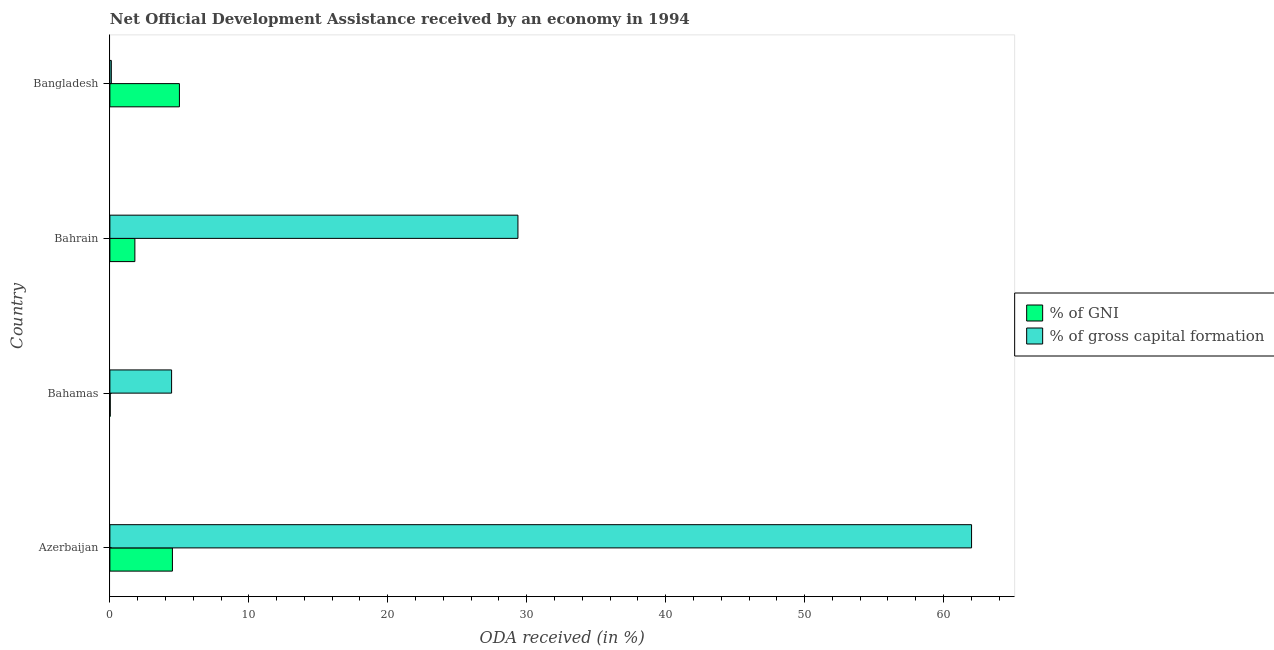Are the number of bars per tick equal to the number of legend labels?
Provide a succinct answer. Yes. Are the number of bars on each tick of the Y-axis equal?
Your answer should be compact. Yes. How many bars are there on the 3rd tick from the top?
Your answer should be compact. 2. How many bars are there on the 4th tick from the bottom?
Keep it short and to the point. 2. What is the label of the 2nd group of bars from the top?
Keep it short and to the point. Bahrain. In how many cases, is the number of bars for a given country not equal to the number of legend labels?
Offer a terse response. 0. What is the oda received as percentage of gross capital formation in Bangladesh?
Ensure brevity in your answer.  0.1. Across all countries, what is the maximum oda received as percentage of gni?
Provide a succinct answer. 5. Across all countries, what is the minimum oda received as percentage of gross capital formation?
Offer a very short reply. 0.1. In which country was the oda received as percentage of gross capital formation minimum?
Your response must be concise. Bangladesh. What is the total oda received as percentage of gross capital formation in the graph?
Ensure brevity in your answer.  95.93. What is the difference between the oda received as percentage of gni in Bahrain and that in Bangladesh?
Provide a succinct answer. -3.21. What is the difference between the oda received as percentage of gross capital formation in Bangladesh and the oda received as percentage of gni in Azerbaijan?
Your response must be concise. -4.4. What is the average oda received as percentage of gross capital formation per country?
Your answer should be compact. 23.98. What is the difference between the oda received as percentage of gross capital formation and oda received as percentage of gni in Azerbaijan?
Ensure brevity in your answer.  57.52. In how many countries, is the oda received as percentage of gross capital formation greater than 34 %?
Offer a terse response. 1. What is the ratio of the oda received as percentage of gross capital formation in Azerbaijan to that in Bahrain?
Your answer should be compact. 2.11. Is the oda received as percentage of gross capital formation in Bahamas less than that in Bangladesh?
Keep it short and to the point. No. Is the difference between the oda received as percentage of gross capital formation in Azerbaijan and Bahrain greater than the difference between the oda received as percentage of gni in Azerbaijan and Bahrain?
Provide a short and direct response. Yes. What is the difference between the highest and the second highest oda received as percentage of gross capital formation?
Provide a short and direct response. 32.65. What is the difference between the highest and the lowest oda received as percentage of gross capital formation?
Ensure brevity in your answer.  61.92. Is the sum of the oda received as percentage of gross capital formation in Bahamas and Bahrain greater than the maximum oda received as percentage of gni across all countries?
Offer a terse response. Yes. What does the 2nd bar from the top in Bangladesh represents?
Provide a succinct answer. % of GNI. What does the 1st bar from the bottom in Bahamas represents?
Provide a short and direct response. % of GNI. How many bars are there?
Offer a very short reply. 8. Are all the bars in the graph horizontal?
Ensure brevity in your answer.  Yes. How many countries are there in the graph?
Give a very brief answer. 4. What is the difference between two consecutive major ticks on the X-axis?
Your answer should be compact. 10. Where does the legend appear in the graph?
Provide a succinct answer. Center right. How many legend labels are there?
Provide a succinct answer. 2. What is the title of the graph?
Keep it short and to the point. Net Official Development Assistance received by an economy in 1994. Does "RDB concessional" appear as one of the legend labels in the graph?
Provide a succinct answer. No. What is the label or title of the X-axis?
Keep it short and to the point. ODA received (in %). What is the label or title of the Y-axis?
Provide a short and direct response. Country. What is the ODA received (in %) of % of GNI in Azerbaijan?
Provide a succinct answer. 4.5. What is the ODA received (in %) of % of gross capital formation in Azerbaijan?
Make the answer very short. 62.02. What is the ODA received (in %) in % of GNI in Bahamas?
Offer a very short reply. 0.02. What is the ODA received (in %) in % of gross capital formation in Bahamas?
Make the answer very short. 4.44. What is the ODA received (in %) of % of GNI in Bahrain?
Offer a very short reply. 1.8. What is the ODA received (in %) of % of gross capital formation in Bahrain?
Give a very brief answer. 29.37. What is the ODA received (in %) of % of GNI in Bangladesh?
Keep it short and to the point. 5. What is the ODA received (in %) of % of gross capital formation in Bangladesh?
Make the answer very short. 0.1. Across all countries, what is the maximum ODA received (in %) in % of GNI?
Make the answer very short. 5. Across all countries, what is the maximum ODA received (in %) of % of gross capital formation?
Your answer should be very brief. 62.02. Across all countries, what is the minimum ODA received (in %) in % of GNI?
Ensure brevity in your answer.  0.02. Across all countries, what is the minimum ODA received (in %) of % of gross capital formation?
Offer a very short reply. 0.1. What is the total ODA received (in %) of % of GNI in the graph?
Offer a terse response. 11.33. What is the total ODA received (in %) of % of gross capital formation in the graph?
Your answer should be very brief. 95.93. What is the difference between the ODA received (in %) in % of GNI in Azerbaijan and that in Bahamas?
Provide a succinct answer. 4.48. What is the difference between the ODA received (in %) of % of gross capital formation in Azerbaijan and that in Bahamas?
Give a very brief answer. 57.58. What is the difference between the ODA received (in %) of % of GNI in Azerbaijan and that in Bahrain?
Keep it short and to the point. 2.7. What is the difference between the ODA received (in %) in % of gross capital formation in Azerbaijan and that in Bahrain?
Your response must be concise. 32.65. What is the difference between the ODA received (in %) in % of GNI in Azerbaijan and that in Bangladesh?
Provide a succinct answer. -0.5. What is the difference between the ODA received (in %) of % of gross capital formation in Azerbaijan and that in Bangladesh?
Provide a succinct answer. 61.92. What is the difference between the ODA received (in %) of % of GNI in Bahamas and that in Bahrain?
Your answer should be compact. -1.78. What is the difference between the ODA received (in %) in % of gross capital formation in Bahamas and that in Bahrain?
Provide a succinct answer. -24.93. What is the difference between the ODA received (in %) of % of GNI in Bahamas and that in Bangladesh?
Your answer should be compact. -4.98. What is the difference between the ODA received (in %) of % of gross capital formation in Bahamas and that in Bangladesh?
Your answer should be very brief. 4.34. What is the difference between the ODA received (in %) in % of GNI in Bahrain and that in Bangladesh?
Make the answer very short. -3.21. What is the difference between the ODA received (in %) in % of gross capital formation in Bahrain and that in Bangladesh?
Your response must be concise. 29.27. What is the difference between the ODA received (in %) in % of GNI in Azerbaijan and the ODA received (in %) in % of gross capital formation in Bahamas?
Give a very brief answer. 0.06. What is the difference between the ODA received (in %) in % of GNI in Azerbaijan and the ODA received (in %) in % of gross capital formation in Bahrain?
Provide a short and direct response. -24.87. What is the difference between the ODA received (in %) in % of GNI in Azerbaijan and the ODA received (in %) in % of gross capital formation in Bangladesh?
Offer a very short reply. 4.4. What is the difference between the ODA received (in %) in % of GNI in Bahamas and the ODA received (in %) in % of gross capital formation in Bahrain?
Provide a short and direct response. -29.35. What is the difference between the ODA received (in %) of % of GNI in Bahamas and the ODA received (in %) of % of gross capital formation in Bangladesh?
Your response must be concise. -0.08. What is the difference between the ODA received (in %) of % of GNI in Bahrain and the ODA received (in %) of % of gross capital formation in Bangladesh?
Your response must be concise. 1.7. What is the average ODA received (in %) in % of GNI per country?
Make the answer very short. 2.83. What is the average ODA received (in %) of % of gross capital formation per country?
Your response must be concise. 23.98. What is the difference between the ODA received (in %) of % of GNI and ODA received (in %) of % of gross capital formation in Azerbaijan?
Your response must be concise. -57.52. What is the difference between the ODA received (in %) in % of GNI and ODA received (in %) in % of gross capital formation in Bahamas?
Give a very brief answer. -4.42. What is the difference between the ODA received (in %) of % of GNI and ODA received (in %) of % of gross capital formation in Bahrain?
Provide a succinct answer. -27.57. What is the difference between the ODA received (in %) in % of GNI and ODA received (in %) in % of gross capital formation in Bangladesh?
Your answer should be very brief. 4.9. What is the ratio of the ODA received (in %) in % of GNI in Azerbaijan to that in Bahamas?
Offer a terse response. 190.43. What is the ratio of the ODA received (in %) in % of gross capital formation in Azerbaijan to that in Bahamas?
Offer a very short reply. 13.97. What is the ratio of the ODA received (in %) of % of GNI in Azerbaijan to that in Bahrain?
Make the answer very short. 2.5. What is the ratio of the ODA received (in %) of % of gross capital formation in Azerbaijan to that in Bahrain?
Your answer should be compact. 2.11. What is the ratio of the ODA received (in %) in % of GNI in Azerbaijan to that in Bangladesh?
Ensure brevity in your answer.  0.9. What is the ratio of the ODA received (in %) in % of gross capital formation in Azerbaijan to that in Bangladesh?
Make the answer very short. 600.8. What is the ratio of the ODA received (in %) in % of GNI in Bahamas to that in Bahrain?
Provide a succinct answer. 0.01. What is the ratio of the ODA received (in %) in % of gross capital formation in Bahamas to that in Bahrain?
Ensure brevity in your answer.  0.15. What is the ratio of the ODA received (in %) of % of GNI in Bahamas to that in Bangladesh?
Your answer should be compact. 0. What is the ratio of the ODA received (in %) in % of gross capital formation in Bahamas to that in Bangladesh?
Your answer should be very brief. 43.02. What is the ratio of the ODA received (in %) in % of GNI in Bahrain to that in Bangladesh?
Your answer should be compact. 0.36. What is the ratio of the ODA received (in %) in % of gross capital formation in Bahrain to that in Bangladesh?
Provide a succinct answer. 284.51. What is the difference between the highest and the second highest ODA received (in %) in % of GNI?
Offer a very short reply. 0.5. What is the difference between the highest and the second highest ODA received (in %) of % of gross capital formation?
Offer a very short reply. 32.65. What is the difference between the highest and the lowest ODA received (in %) of % of GNI?
Provide a succinct answer. 4.98. What is the difference between the highest and the lowest ODA received (in %) in % of gross capital formation?
Your answer should be very brief. 61.92. 